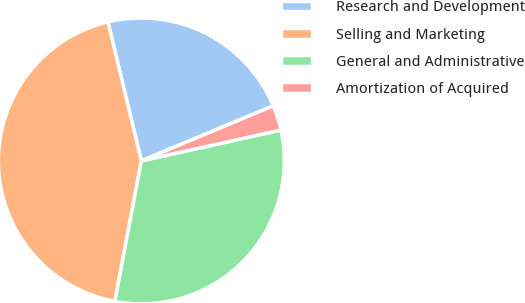Convert chart to OTSL. <chart><loc_0><loc_0><loc_500><loc_500><pie_chart><fcel>Research and Development<fcel>Selling and Marketing<fcel>General and Administrative<fcel>Amortization of Acquired<nl><fcel>22.46%<fcel>43.28%<fcel>31.43%<fcel>2.83%<nl></chart> 